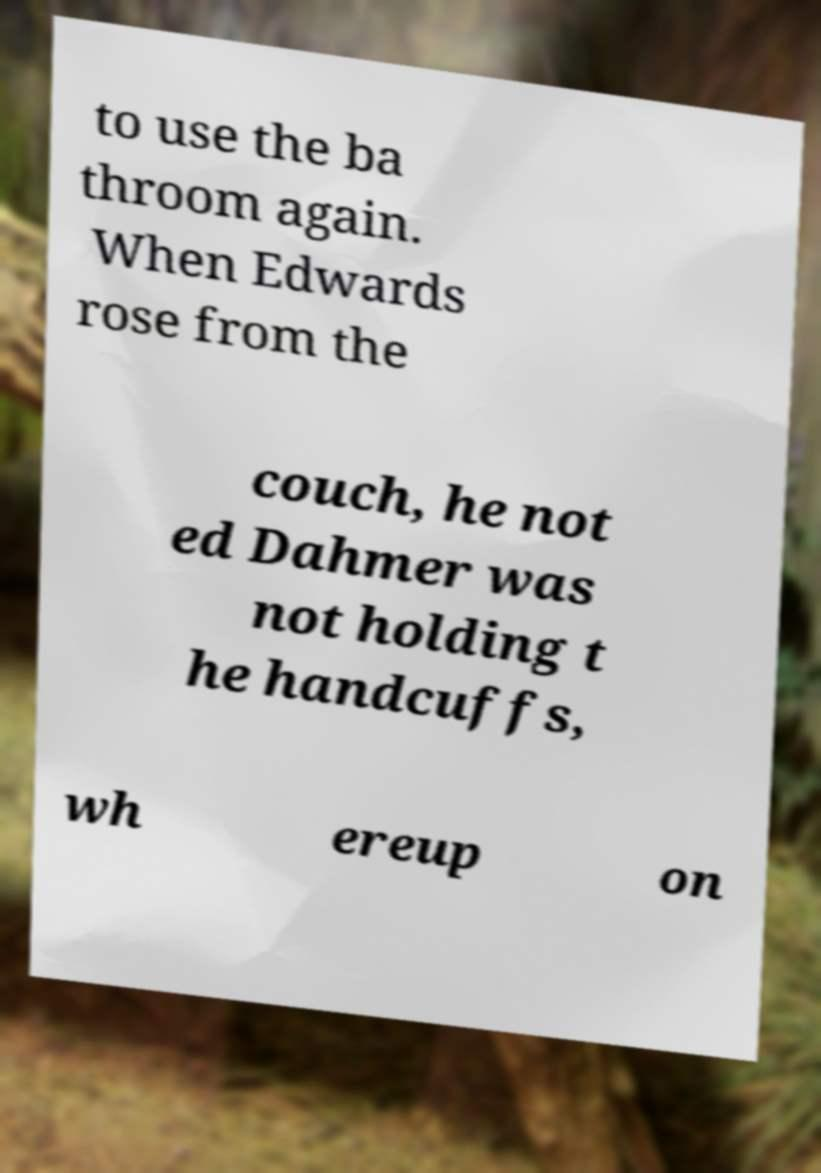Please read and relay the text visible in this image. What does it say? to use the ba throom again. When Edwards rose from the couch, he not ed Dahmer was not holding t he handcuffs, wh ereup on 